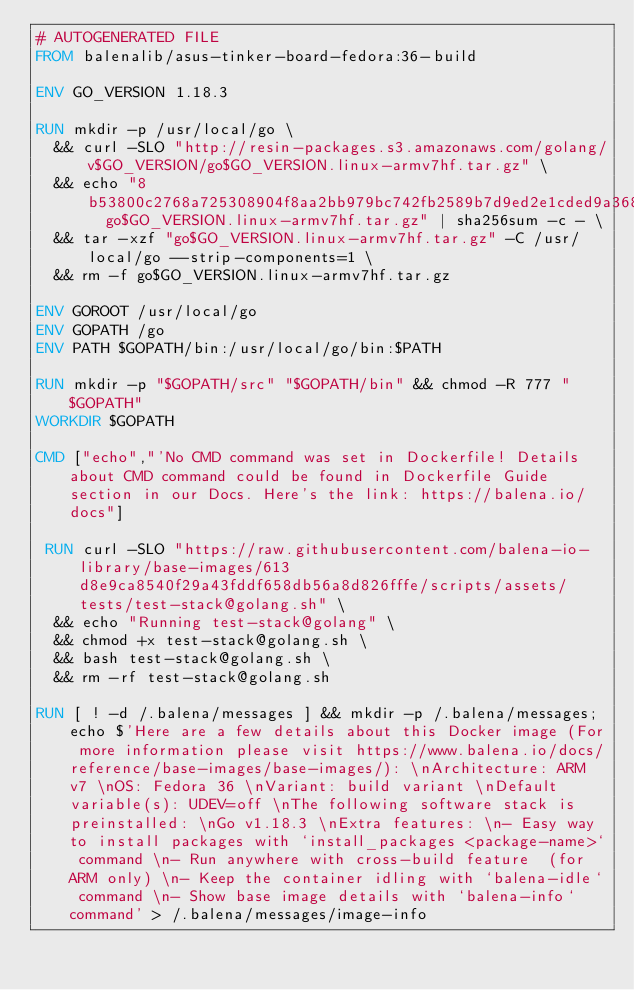<code> <loc_0><loc_0><loc_500><loc_500><_Dockerfile_># AUTOGENERATED FILE
FROM balenalib/asus-tinker-board-fedora:36-build

ENV GO_VERSION 1.18.3

RUN mkdir -p /usr/local/go \
	&& curl -SLO "http://resin-packages.s3.amazonaws.com/golang/v$GO_VERSION/go$GO_VERSION.linux-armv7hf.tar.gz" \
	&& echo "8b53800c2768a725308904f8aa2bb979bc742fb2589b7d9ed2e1cded9a368100  go$GO_VERSION.linux-armv7hf.tar.gz" | sha256sum -c - \
	&& tar -xzf "go$GO_VERSION.linux-armv7hf.tar.gz" -C /usr/local/go --strip-components=1 \
	&& rm -f go$GO_VERSION.linux-armv7hf.tar.gz

ENV GOROOT /usr/local/go
ENV GOPATH /go
ENV PATH $GOPATH/bin:/usr/local/go/bin:$PATH

RUN mkdir -p "$GOPATH/src" "$GOPATH/bin" && chmod -R 777 "$GOPATH"
WORKDIR $GOPATH

CMD ["echo","'No CMD command was set in Dockerfile! Details about CMD command could be found in Dockerfile Guide section in our Docs. Here's the link: https://balena.io/docs"]

 RUN curl -SLO "https://raw.githubusercontent.com/balena-io-library/base-images/613d8e9ca8540f29a43fddf658db56a8d826fffe/scripts/assets/tests/test-stack@golang.sh" \
  && echo "Running test-stack@golang" \
  && chmod +x test-stack@golang.sh \
  && bash test-stack@golang.sh \
  && rm -rf test-stack@golang.sh 

RUN [ ! -d /.balena/messages ] && mkdir -p /.balena/messages; echo $'Here are a few details about this Docker image (For more information please visit https://www.balena.io/docs/reference/base-images/base-images/): \nArchitecture: ARM v7 \nOS: Fedora 36 \nVariant: build variant \nDefault variable(s): UDEV=off \nThe following software stack is preinstalled: \nGo v1.18.3 \nExtra features: \n- Easy way to install packages with `install_packages <package-name>` command \n- Run anywhere with cross-build feature  (for ARM only) \n- Keep the container idling with `balena-idle` command \n- Show base image details with `balena-info` command' > /.balena/messages/image-info</code> 